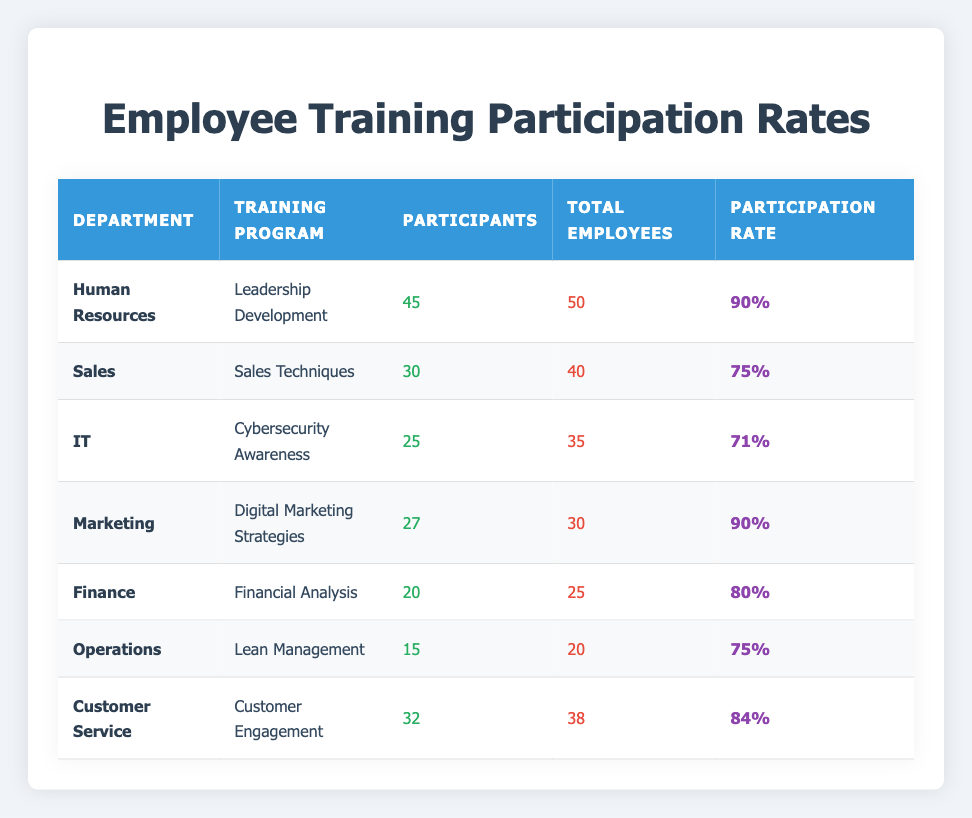What is the participation rate for the Human Resources department in the Leadership Development training program? The participation rate is found by taking the number of participants (45) and dividing it by the total employees (50), then multiplying by 100. Thus, (45/50) * 100 = 90%.
Answer: 90% Which department had the highest number of training participants? By comparing the number of participants across all departments, Human Resources has 45 participants, which is the highest compared to others: Sales (30), IT (25), Marketing (27), Finance (20), Operations (15), and Customer Service (32).
Answer: Human Resources Is the participation rate for Customer Service higher than that for Finance? The participation rate for Customer Service is 84% (32 participants out of 38 total), while for Finance it is 80% (20 participants out of 25 total). Since 84% is greater than 80%, the statement is true.
Answer: Yes What is the average participation rate across all departments? To calculate the average, first, find the participation rates for each department: Human Resources (90%), Sales (75%), IT (71%), Marketing (90%), Finance (80%), Operations (75%), and Customer Service (84%). Adding them gives 90 + 75 + 71 + 90 + 80 + 75 + 84 = 555, and dividing by 7 (the number of departments) results in an average of 555/7 = 79.29%.
Answer: 79.29% Does the IT department have more total employees than the Operations department? IT has 35 total employees while Operations has 20. Since 35 is greater than 20, the statement is true.
Answer: Yes Which training program has a participation rate that is equal to the average participation rate calculated? From the previous calculations, the average participation rate is 79.29%. Checking the rates, we find that none equal this average. The closest is Finance at 80%, but it’s not the same.
Answer: None What is the total number of participants in the Marketing and IT departments combined? Adding the participants from both departments: Marketing (27) + IT (25) = 52.
Answer: 52 Which department has a lower participation rate, Sales or Operations? Sales has a participation rate of 75% (30 participants out of 40 total), while Operations has a participation rate of 75% (15 participants out of 20 total). Since both are equal, neither has a lower rate.
Answer: Neither 